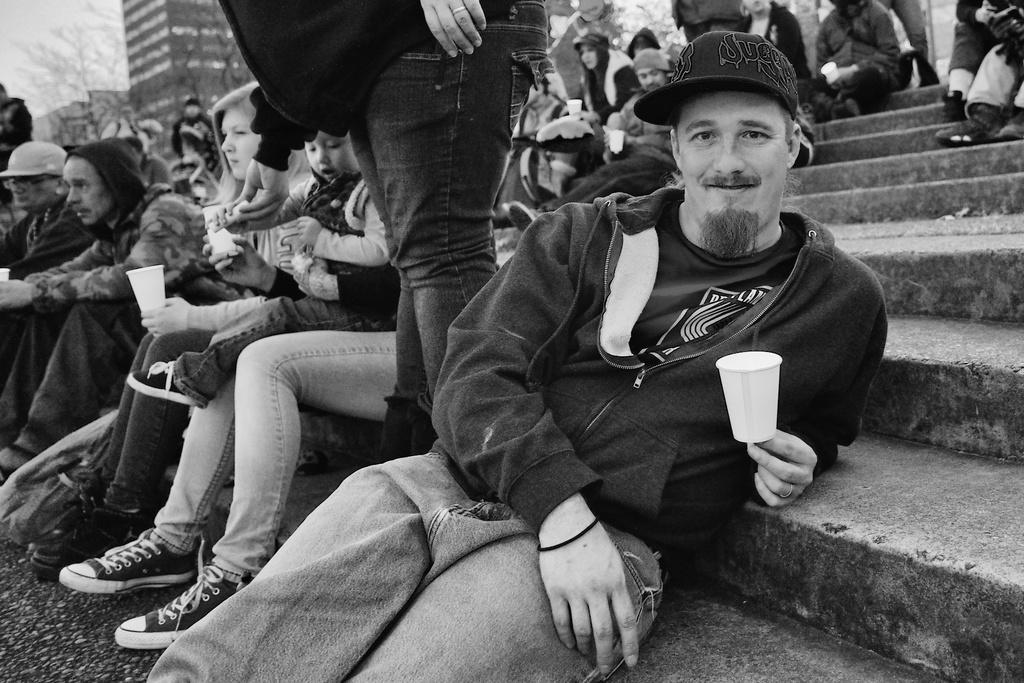In one or two sentences, can you explain what this image depicts? This is the black and white image where we can see this person wearing jacket and cap is holding a cup in his hands. Here we can see this person is standing and these people are sitting on the steps. In the background, we can see buildings, trees and the sky. 